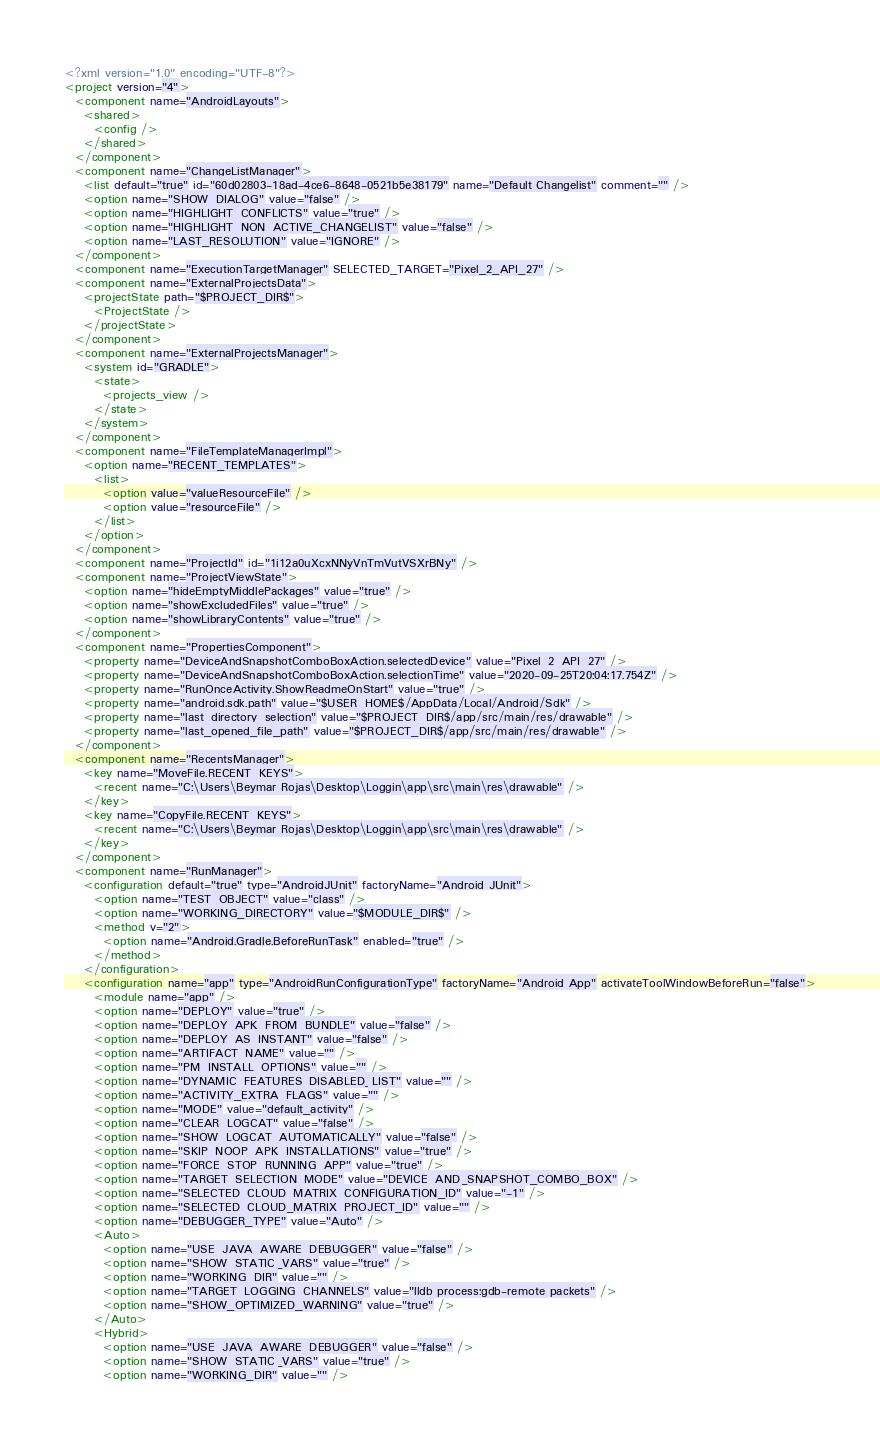<code> <loc_0><loc_0><loc_500><loc_500><_XML_><?xml version="1.0" encoding="UTF-8"?>
<project version="4">
  <component name="AndroidLayouts">
    <shared>
      <config />
    </shared>
  </component>
  <component name="ChangeListManager">
    <list default="true" id="60d02803-18ad-4ce6-8648-0521b5e38179" name="Default Changelist" comment="" />
    <option name="SHOW_DIALOG" value="false" />
    <option name="HIGHLIGHT_CONFLICTS" value="true" />
    <option name="HIGHLIGHT_NON_ACTIVE_CHANGELIST" value="false" />
    <option name="LAST_RESOLUTION" value="IGNORE" />
  </component>
  <component name="ExecutionTargetManager" SELECTED_TARGET="Pixel_2_API_27" />
  <component name="ExternalProjectsData">
    <projectState path="$PROJECT_DIR$">
      <ProjectState />
    </projectState>
  </component>
  <component name="ExternalProjectsManager">
    <system id="GRADLE">
      <state>
        <projects_view />
      </state>
    </system>
  </component>
  <component name="FileTemplateManagerImpl">
    <option name="RECENT_TEMPLATES">
      <list>
        <option value="valueResourceFile" />
        <option value="resourceFile" />
      </list>
    </option>
  </component>
  <component name="ProjectId" id="1i12a0uXcxNNyVnTmVutVSXrBNy" />
  <component name="ProjectViewState">
    <option name="hideEmptyMiddlePackages" value="true" />
    <option name="showExcludedFiles" value="true" />
    <option name="showLibraryContents" value="true" />
  </component>
  <component name="PropertiesComponent">
    <property name="DeviceAndSnapshotComboBoxAction.selectedDevice" value="Pixel_2_API_27" />
    <property name="DeviceAndSnapshotComboBoxAction.selectionTime" value="2020-09-25T20:04:17.754Z" />
    <property name="RunOnceActivity.ShowReadmeOnStart" value="true" />
    <property name="android.sdk.path" value="$USER_HOME$/AppData/Local/Android/Sdk" />
    <property name="last_directory_selection" value="$PROJECT_DIR$/app/src/main/res/drawable" />
    <property name="last_opened_file_path" value="$PROJECT_DIR$/app/src/main/res/drawable" />
  </component>
  <component name="RecentsManager">
    <key name="MoveFile.RECENT_KEYS">
      <recent name="C:\Users\Beymar Rojas\Desktop\Loggin\app\src\main\res\drawable" />
    </key>
    <key name="CopyFile.RECENT_KEYS">
      <recent name="C:\Users\Beymar Rojas\Desktop\Loggin\app\src\main\res\drawable" />
    </key>
  </component>
  <component name="RunManager">
    <configuration default="true" type="AndroidJUnit" factoryName="Android JUnit">
      <option name="TEST_OBJECT" value="class" />
      <option name="WORKING_DIRECTORY" value="$MODULE_DIR$" />
      <method v="2">
        <option name="Android.Gradle.BeforeRunTask" enabled="true" />
      </method>
    </configuration>
    <configuration name="app" type="AndroidRunConfigurationType" factoryName="Android App" activateToolWindowBeforeRun="false">
      <module name="app" />
      <option name="DEPLOY" value="true" />
      <option name="DEPLOY_APK_FROM_BUNDLE" value="false" />
      <option name="DEPLOY_AS_INSTANT" value="false" />
      <option name="ARTIFACT_NAME" value="" />
      <option name="PM_INSTALL_OPTIONS" value="" />
      <option name="DYNAMIC_FEATURES_DISABLED_LIST" value="" />
      <option name="ACTIVITY_EXTRA_FLAGS" value="" />
      <option name="MODE" value="default_activity" />
      <option name="CLEAR_LOGCAT" value="false" />
      <option name="SHOW_LOGCAT_AUTOMATICALLY" value="false" />
      <option name="SKIP_NOOP_APK_INSTALLATIONS" value="true" />
      <option name="FORCE_STOP_RUNNING_APP" value="true" />
      <option name="TARGET_SELECTION_MODE" value="DEVICE_AND_SNAPSHOT_COMBO_BOX" />
      <option name="SELECTED_CLOUD_MATRIX_CONFIGURATION_ID" value="-1" />
      <option name="SELECTED_CLOUD_MATRIX_PROJECT_ID" value="" />
      <option name="DEBUGGER_TYPE" value="Auto" />
      <Auto>
        <option name="USE_JAVA_AWARE_DEBUGGER" value="false" />
        <option name="SHOW_STATIC_VARS" value="true" />
        <option name="WORKING_DIR" value="" />
        <option name="TARGET_LOGGING_CHANNELS" value="lldb process:gdb-remote packets" />
        <option name="SHOW_OPTIMIZED_WARNING" value="true" />
      </Auto>
      <Hybrid>
        <option name="USE_JAVA_AWARE_DEBUGGER" value="false" />
        <option name="SHOW_STATIC_VARS" value="true" />
        <option name="WORKING_DIR" value="" /></code> 